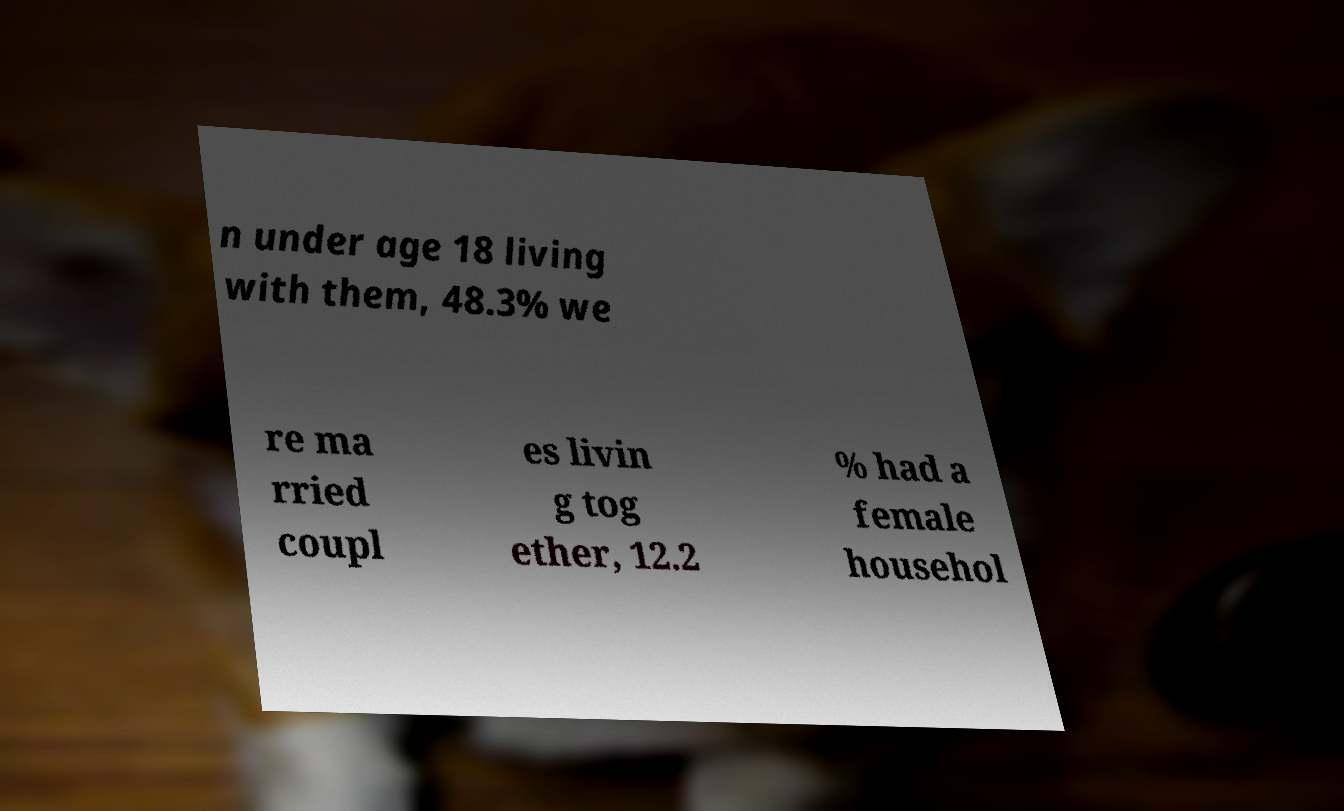Could you extract and type out the text from this image? n under age 18 living with them, 48.3% we re ma rried coupl es livin g tog ether, 12.2 % had a female househol 